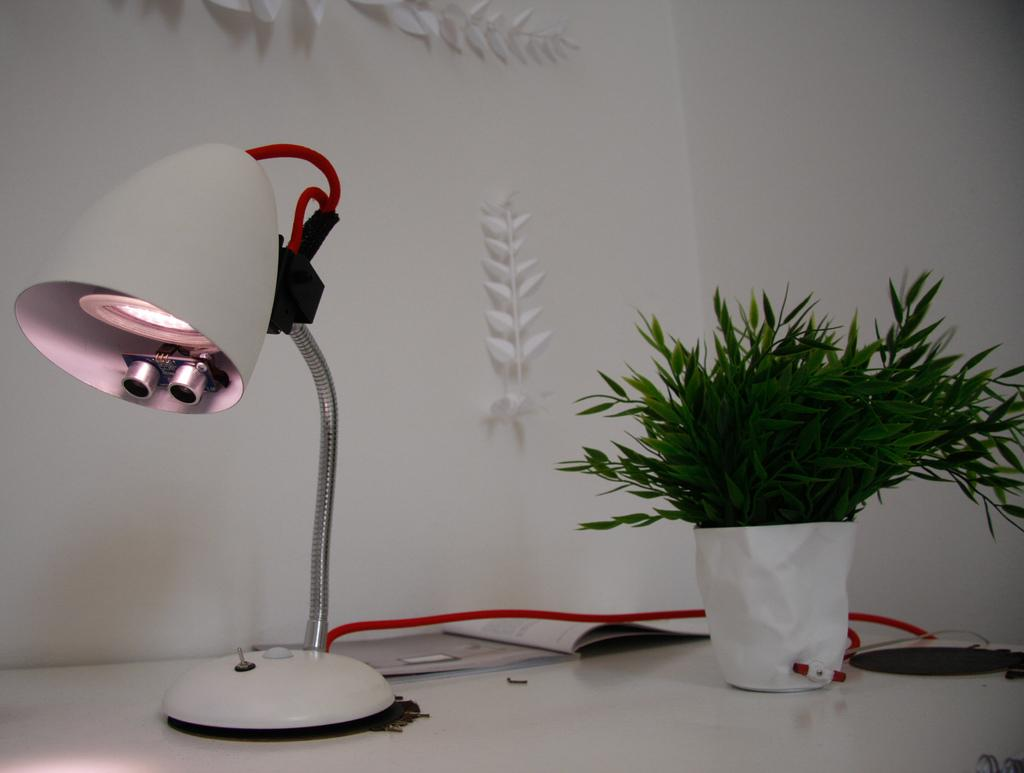What type of lighting is present in the image? There is a table lamp in the image. What other object can be seen in the image? There is a plant in the image. What color is the surface in the image? The surface in the image is white. What can be seen in the background of the image? There is a wall in the background of the image. What type of apparel is being worn by the plant in the image? There is no apparel present in the image, as the plant is an inanimate object. How many marks can be seen on the wall in the image? There is no mention of marks on the wall in the image, so it cannot be determined. 